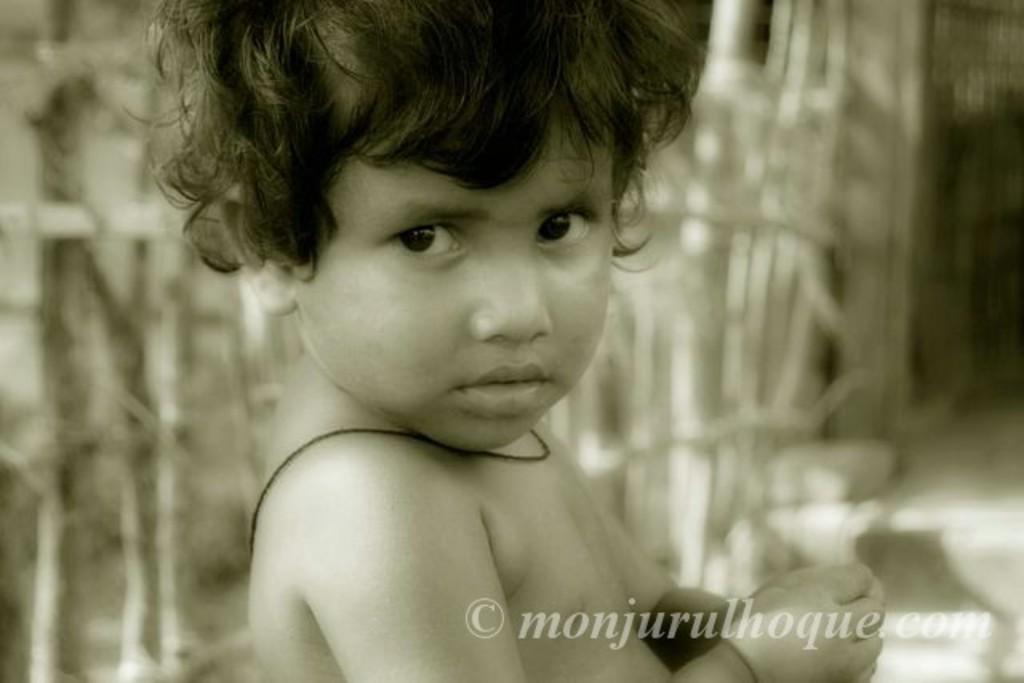Could you give a brief overview of what you see in this image? In this image, we can see a kid. There is a blurred background in the image. In the bottom right corner, there is a watermark in the image. 